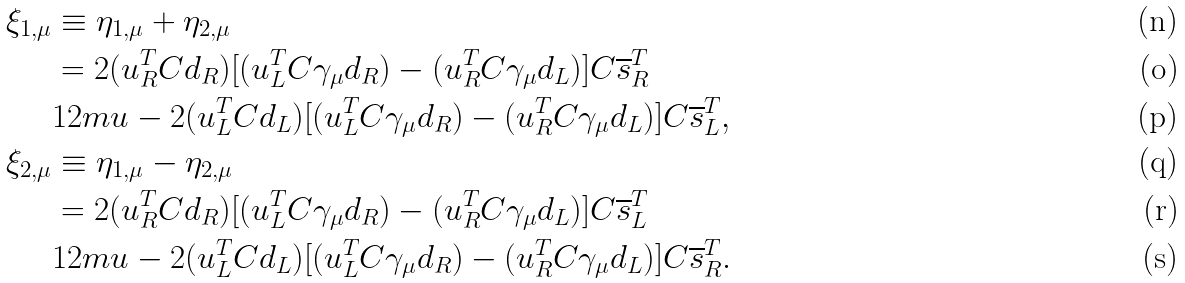Convert formula to latex. <formula><loc_0><loc_0><loc_500><loc_500>\xi _ { 1 , \mu } & \equiv \eta _ { 1 , \mu } + \eta _ { 2 , \mu } \\ & = 2 ( u ^ { T } _ { R } C d _ { R } ) [ ( u ^ { T } _ { L } C \gamma _ { \mu } d _ { R } ) - ( u ^ { T } _ { R } C \gamma _ { \mu } d _ { L } ) ] C \overline { s } ^ { T } _ { R } \\ & { 1 2 m u } - 2 ( u ^ { T } _ { L } C d _ { L } ) [ ( u ^ { T } _ { L } C \gamma _ { \mu } d _ { R } ) - ( u ^ { T } _ { R } C \gamma _ { \mu } d _ { L } ) ] C \overline { s } ^ { T } _ { L } , \\ \xi _ { 2 , \mu } & \equiv \eta _ { 1 , \mu } - \eta _ { 2 , \mu } \\ & = 2 ( u ^ { T } _ { R } C d _ { R } ) [ ( u ^ { T } _ { L } C \gamma _ { \mu } d _ { R } ) - ( u ^ { T } _ { R } C \gamma _ { \mu } d _ { L } ) ] C \overline { s } ^ { T } _ { L } \\ & { 1 2 m u } - 2 ( u ^ { T } _ { L } C d _ { L } ) [ ( u ^ { T } _ { L } C \gamma _ { \mu } d _ { R } ) - ( u ^ { T } _ { R } C \gamma _ { \mu } d _ { L } ) ] C \overline { s } ^ { T } _ { R } .</formula> 